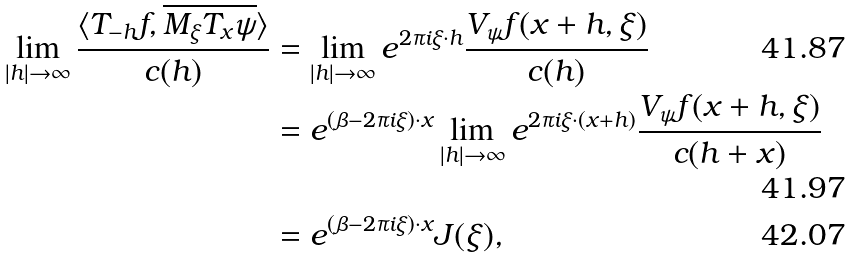<formula> <loc_0><loc_0><loc_500><loc_500>\lim _ { | h | \to \infty } \frac { \langle T _ { - h } f , \overline { M _ { \xi } T _ { x } \psi } \rangle } { c ( h ) } & = \lim _ { | h | \to \infty } e ^ { 2 \pi i \xi \cdot h } \frac { V _ { \psi } f ( x + h , \xi ) } { c ( h ) } \\ & = e ^ { ( \beta - 2 \pi i \xi ) \cdot x } \lim _ { | h | \to \infty } e ^ { 2 \pi i \xi \cdot ( x + h ) } \frac { V _ { \psi } f ( x + h , \xi ) } { c ( h + x ) } \\ & = e ^ { ( \beta - 2 \pi i \xi ) \cdot x } J ( \xi ) ,</formula> 